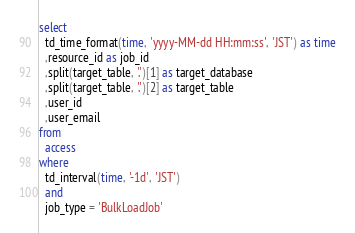Convert code to text. <code><loc_0><loc_0><loc_500><loc_500><_SQL_>select
  td_time_format(time, 'yyyy-MM-dd HH:mm:ss', 'JST') as time
  ,resource_id as job_id
  ,split(target_table, '.')[1] as target_database
  ,split(target_table, '.')[2] as target_table
  ,user_id
  ,user_email
from
  access
where
  td_interval(time, '-1d', 'JST')
  and
  job_type = 'BulkLoadJob'
</code> 